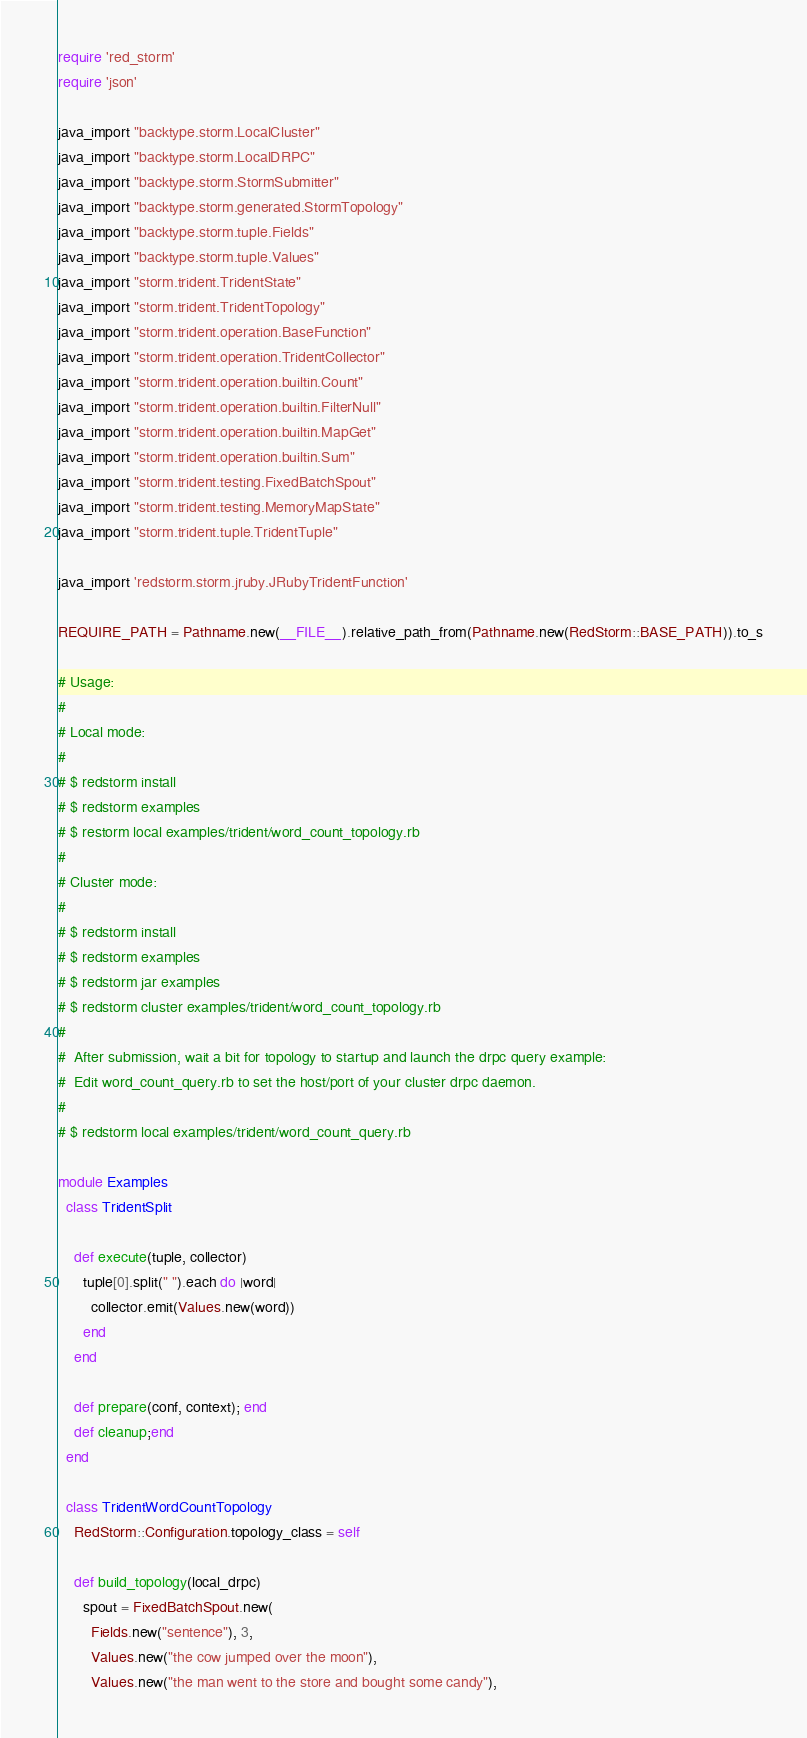<code> <loc_0><loc_0><loc_500><loc_500><_Ruby_>require 'red_storm'
require 'json'

java_import "backtype.storm.LocalCluster"
java_import "backtype.storm.LocalDRPC"
java_import "backtype.storm.StormSubmitter"
java_import "backtype.storm.generated.StormTopology"
java_import "backtype.storm.tuple.Fields"
java_import "backtype.storm.tuple.Values"
java_import "storm.trident.TridentState"
java_import "storm.trident.TridentTopology"
java_import "storm.trident.operation.BaseFunction"
java_import "storm.trident.operation.TridentCollector"
java_import "storm.trident.operation.builtin.Count"
java_import "storm.trident.operation.builtin.FilterNull"
java_import "storm.trident.operation.builtin.MapGet"
java_import "storm.trident.operation.builtin.Sum"
java_import "storm.trident.testing.FixedBatchSpout"
java_import "storm.trident.testing.MemoryMapState"
java_import "storm.trident.tuple.TridentTuple"

java_import 'redstorm.storm.jruby.JRubyTridentFunction'

REQUIRE_PATH = Pathname.new(__FILE__).relative_path_from(Pathname.new(RedStorm::BASE_PATH)).to_s

# Usage:
#
# Local mode:
#
# $ redstorm install
# $ redstorm examples
# $ restorm local examples/trident/word_count_topology.rb
#
# Cluster mode:
#
# $ redstorm install
# $ redstorm examples
# $ redstorm jar examples
# $ redstorm cluster examples/trident/word_count_topology.rb
#
#  After submission, wait a bit for topology to startup and launch the drpc query example:
#  Edit word_count_query.rb to set the host/port of your cluster drpc daemon.
#
# $ redstorm local examples/trident/word_count_query.rb

module Examples
  class TridentSplit

    def execute(tuple, collector)
      tuple[0].split(" ").each do |word|
        collector.emit(Values.new(word))
      end
    end

    def prepare(conf, context); end
    def cleanup;end
  end

  class TridentWordCountTopology
    RedStorm::Configuration.topology_class = self

    def build_topology(local_drpc)
      spout = FixedBatchSpout.new(
        Fields.new("sentence"), 3,
        Values.new("the cow jumped over the moon"),
        Values.new("the man went to the store and bought some candy"),</code> 